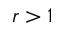<formula> <loc_0><loc_0><loc_500><loc_500>r > 1</formula> 